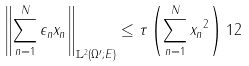<formula> <loc_0><loc_0><loc_500><loc_500>\left \| \sum _ { n = 1 } ^ { N } \epsilon _ { n } x _ { n } \right \| _ { \mathbb { L } ^ { 2 } ( \Omega ^ { \prime } ; E ) } \leq \tau \left ( \sum _ { n = 1 } ^ { N } \| x _ { n } \| ^ { 2 } \right ) ^ { } { 1 } 2</formula> 